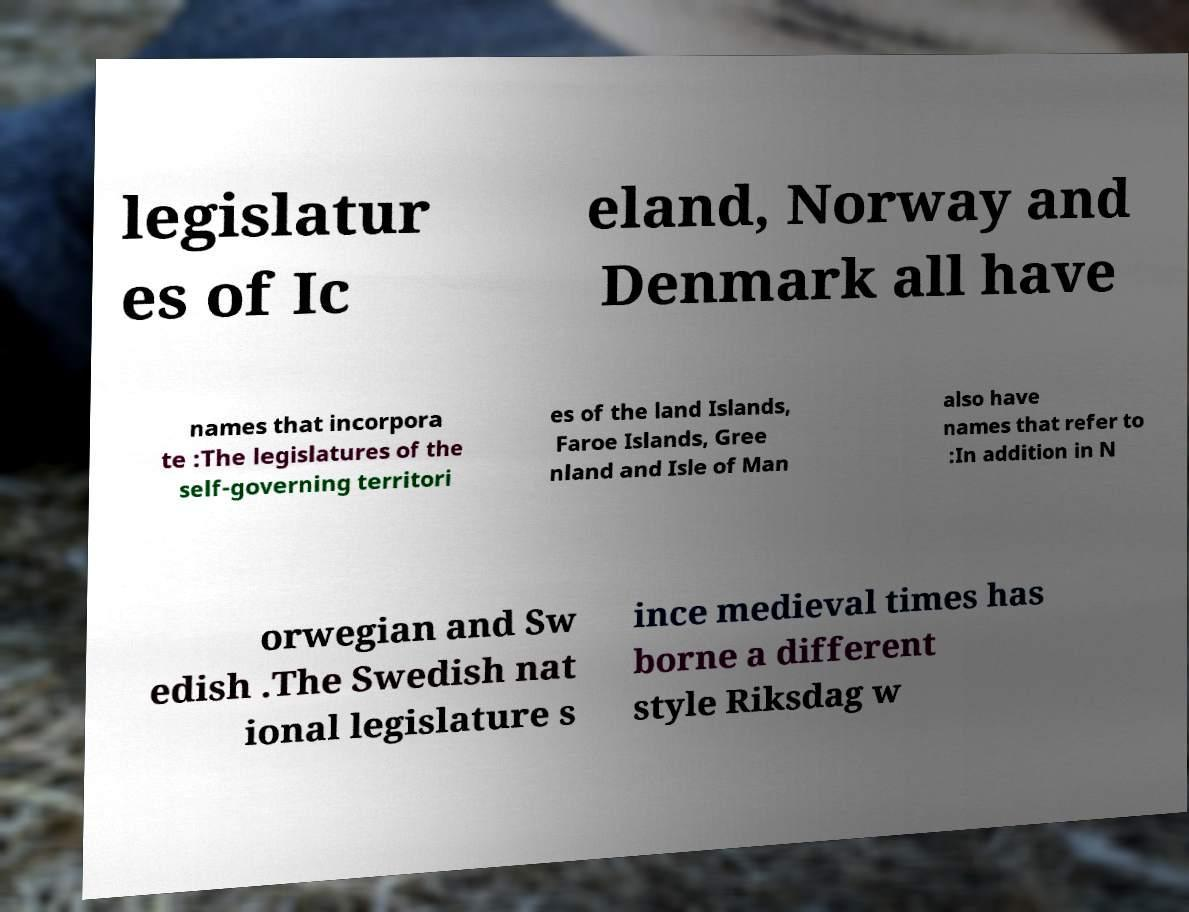There's text embedded in this image that I need extracted. Can you transcribe it verbatim? legislatur es of Ic eland, Norway and Denmark all have names that incorpora te :The legislatures of the self-governing territori es of the land Islands, Faroe Islands, Gree nland and Isle of Man also have names that refer to :In addition in N orwegian and Sw edish .The Swedish nat ional legislature s ince medieval times has borne a different style Riksdag w 